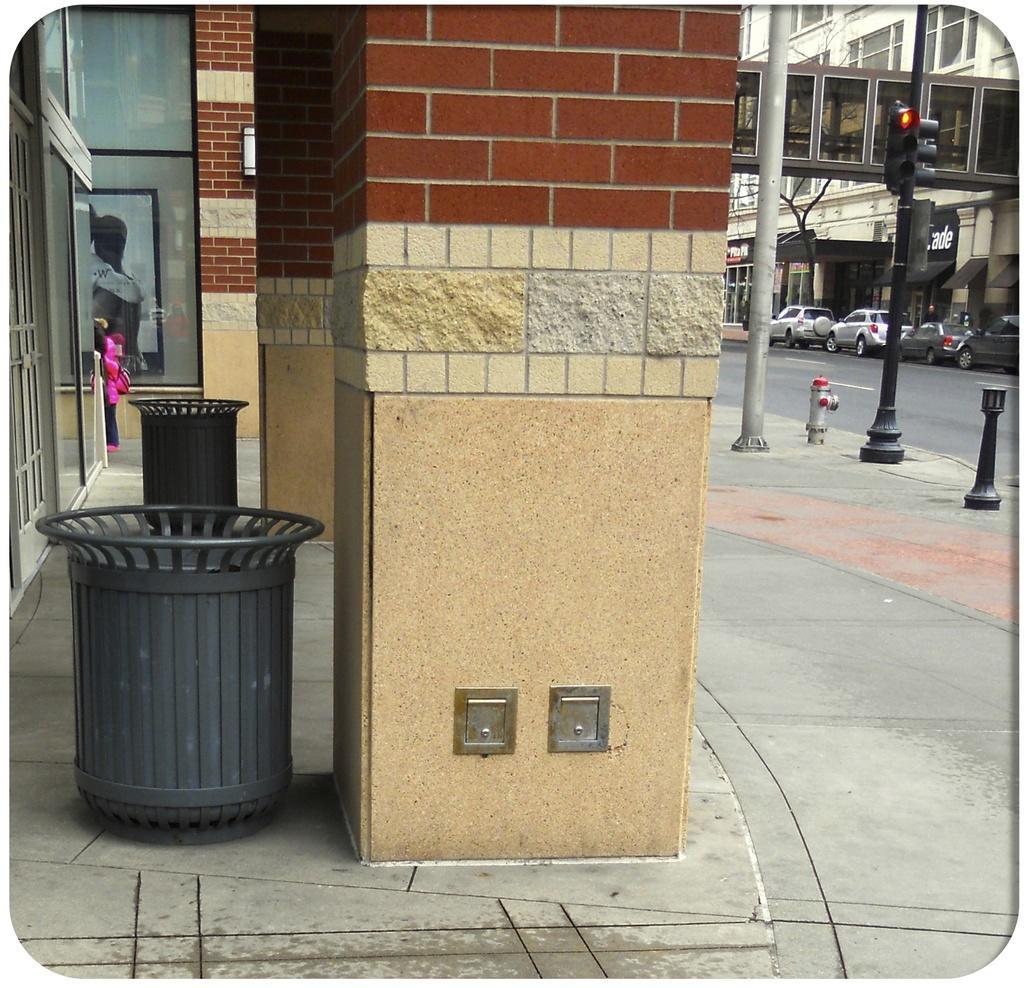Could you give a brief overview of what you see in this image? In this image we can see pillars. Also there are dustbins. In the back there is a glass wall. Also there is a photo frame. We can see traffic signal with pole. In the back there are vehicles on the road. Also there is a bridge and building with windows. 